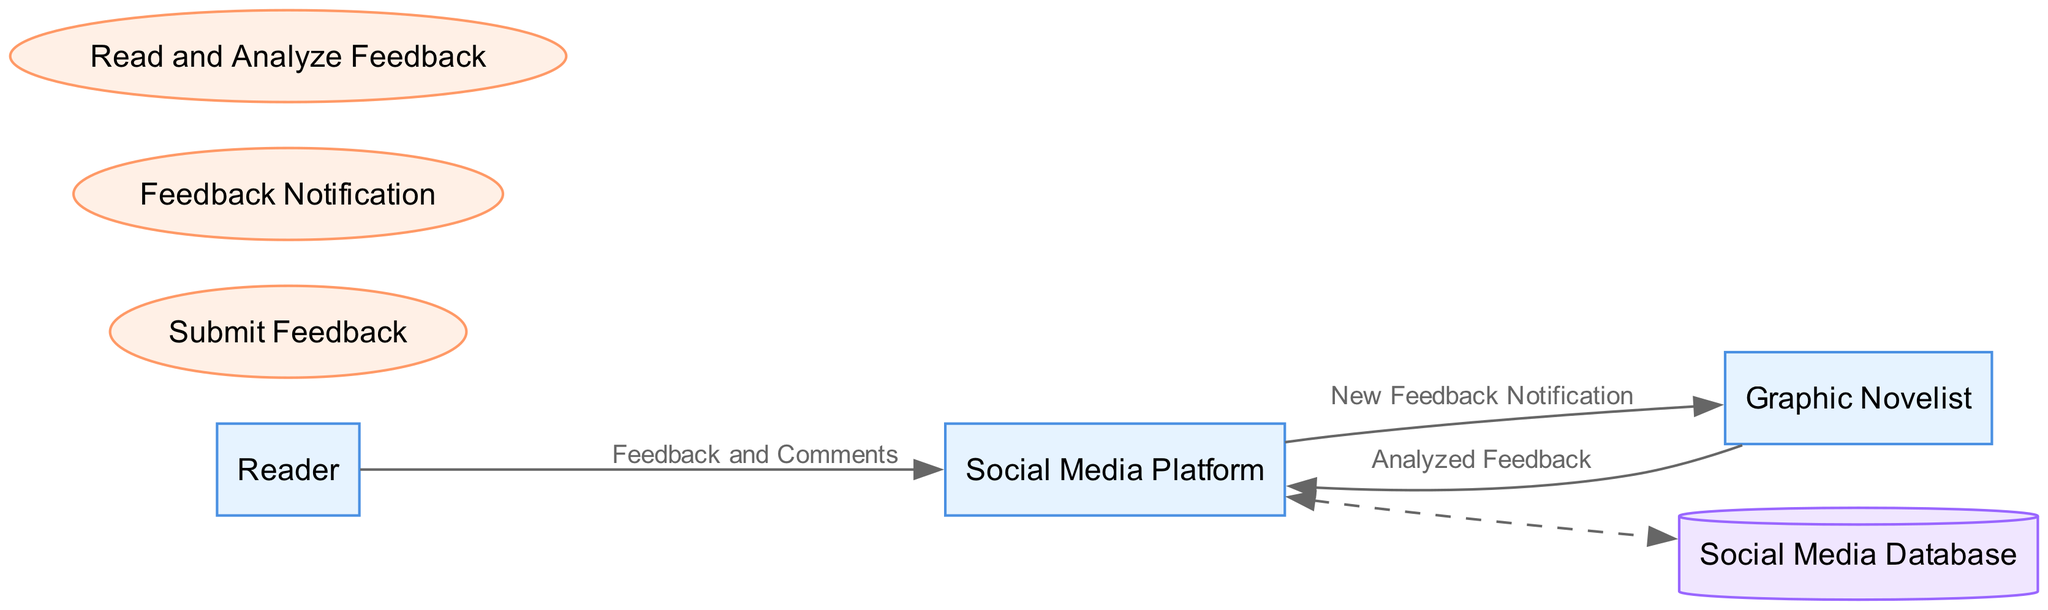What is the primary role of the "Reader"? The "Reader" is described as a passionate reader and fan of the graphic novel who provides feedback and comments, indicating that their main role is to express their thoughts on the work.
Answer: A passionate reader and fan How many entities are present in the diagram? The diagram lists three entities: Reader, Social Media Platform, and Graphic Novelist. Therefore, by counting them, we find that there are three entities in total.
Answer: Three What is the function of the "Feedback Notification" process? The "Feedback Notification" process is described as the process where the social media platform notifies the graphic novelist of new feedback, serving as a communication link for incoming feedback.
Answer: Notifying of new feedback Which entity submits "Feedback and Comments"? According to the diagram, the "Reader" is the entity that submits "Feedback and Comments" to the Social Media Platform, signifying that the readers initiate this communication.
Answer: Reader What type of data flow connects the Social Media Platform to the Graphic Novelist? The diagram specifies the "New Feedback Notification" as the data flow that moves from the Social Media Platform to the Graphic Novelist, indicating the nature of the feedback received.
Answer: New Feedback Notification Describe the relationship between the "Graphic Novelist" and the "Feedback Notification" process. The "Graphic Novelist" is the output recipient of the "Feedback Notification" process; this shows that they receive the notifications generated from readers' comments processed by the social media platform.
Answer: Receives notifications How does the "Analyzed Feedback" flow back to the Social Media Platform? The "Analyzed Feedback" flows from the Graphic Novelist back to the Social Media Platform, suggesting that actions or responses based on feedback can be communicated back to the platform.
Answer: Flows back to the platform What does the Social Media Database store? The Social Media Database is described as storing reader feedback and comments, indicating its role in maintaining this important data for community engagement.
Answer: Reader feedback and comments What is the nature of the connection between the Social Media Platform and the Social Media Database? The connection is represented as a dashed line, indicating a more flexible relationship that allows for bidirectional data flow, meaning that both entities can interact with each other seamlessly.
Answer: Bidirectional data flow 